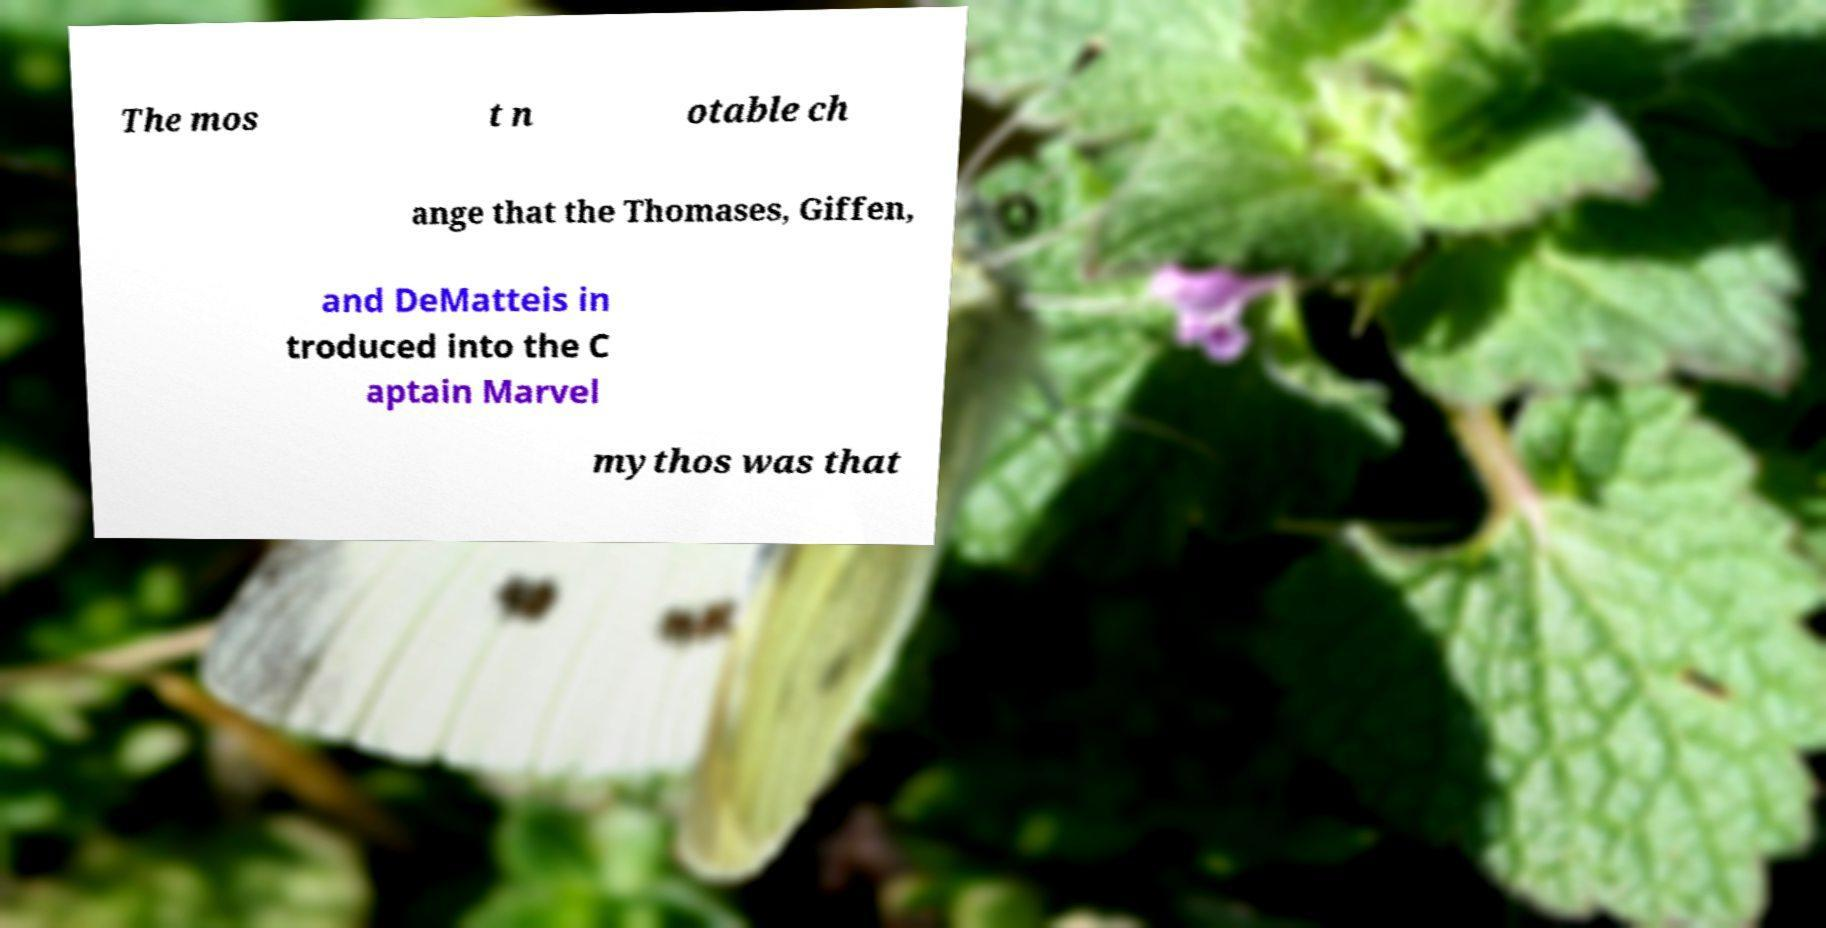Could you assist in decoding the text presented in this image and type it out clearly? The mos t n otable ch ange that the Thomases, Giffen, and DeMatteis in troduced into the C aptain Marvel mythos was that 